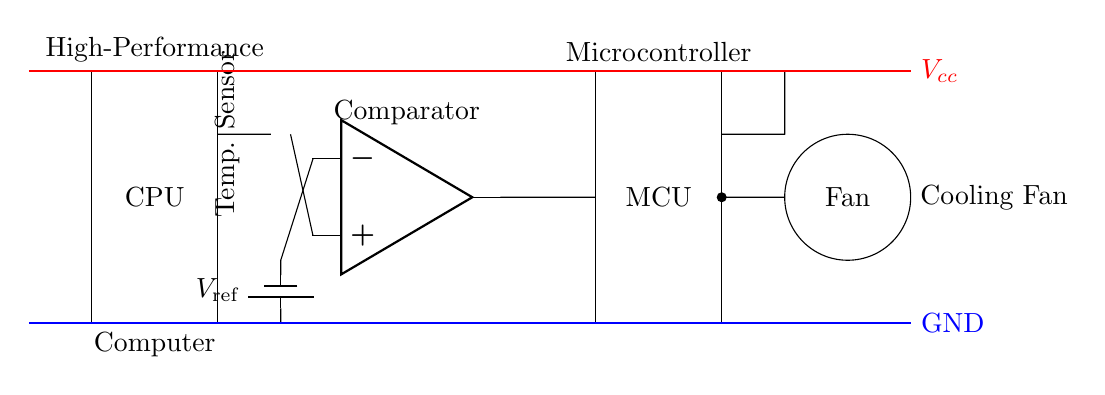What component measures temperature in the circuit? The circuit shows a thermistor, which is a type of temperature sensor that changes resistance based on temperature variations. This is indicated by the symbol labeled "Temp. Sensor" in the diagram.
Answer: Thermistor What is the role of the comparator in this circuit? The comparator compares the voltage from the thermistor with a reference voltage to determine if the temperature exceeds a certain threshold. This functionality is critical in activating the output to control the cooling fan if necessary.
Answer: Control Which component provides the reference voltage? The reference voltage is provided by a battery labeled "V_ref" in the circuit. It is connected to the negative input of the comparator, influencing its output behavior based on temperature readings.
Answer: Battery What is the output of the comparator connected to? The output of the comparator is connected to the microcontroller (MCU), which processes the signal and determines whether to activate the cooling fan based on the temperature threshold.
Answer: Microcontroller Why is there a cooling fan in this circuit? The cooling fan is essential for dissipating heat, ensuring that the high-performance computer operates within safe temperature limits. If the temperature exceeds the threshold determined by the thermistor and comparator, the microcontroller can activate the fan to cool the system.
Answer: Dissipation What does the red line represent in the circuit diagram? The red line represents the positive voltage supply line, denoting the electrical potential provided to the components in the circuit. It’s labeled as "V_cc," indicating the high side of the power supply.
Answer: V_cc 